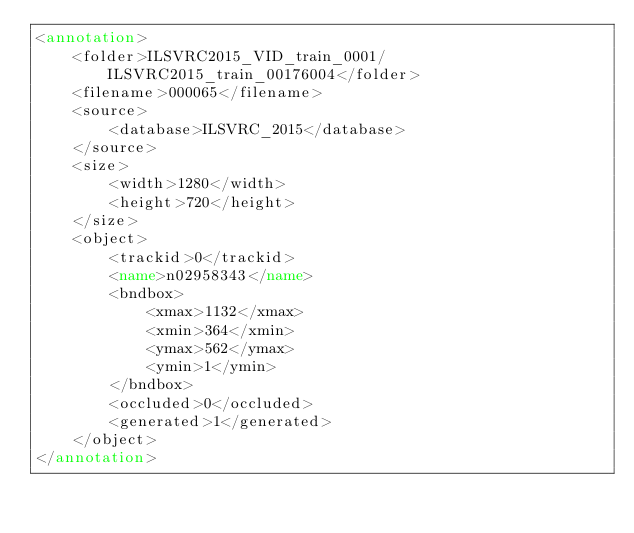<code> <loc_0><loc_0><loc_500><loc_500><_XML_><annotation>
	<folder>ILSVRC2015_VID_train_0001/ILSVRC2015_train_00176004</folder>
	<filename>000065</filename>
	<source>
		<database>ILSVRC_2015</database>
	</source>
	<size>
		<width>1280</width>
		<height>720</height>
	</size>
	<object>
		<trackid>0</trackid>
		<name>n02958343</name>
		<bndbox>
			<xmax>1132</xmax>
			<xmin>364</xmin>
			<ymax>562</ymax>
			<ymin>1</ymin>
		</bndbox>
		<occluded>0</occluded>
		<generated>1</generated>
	</object>
</annotation>
</code> 